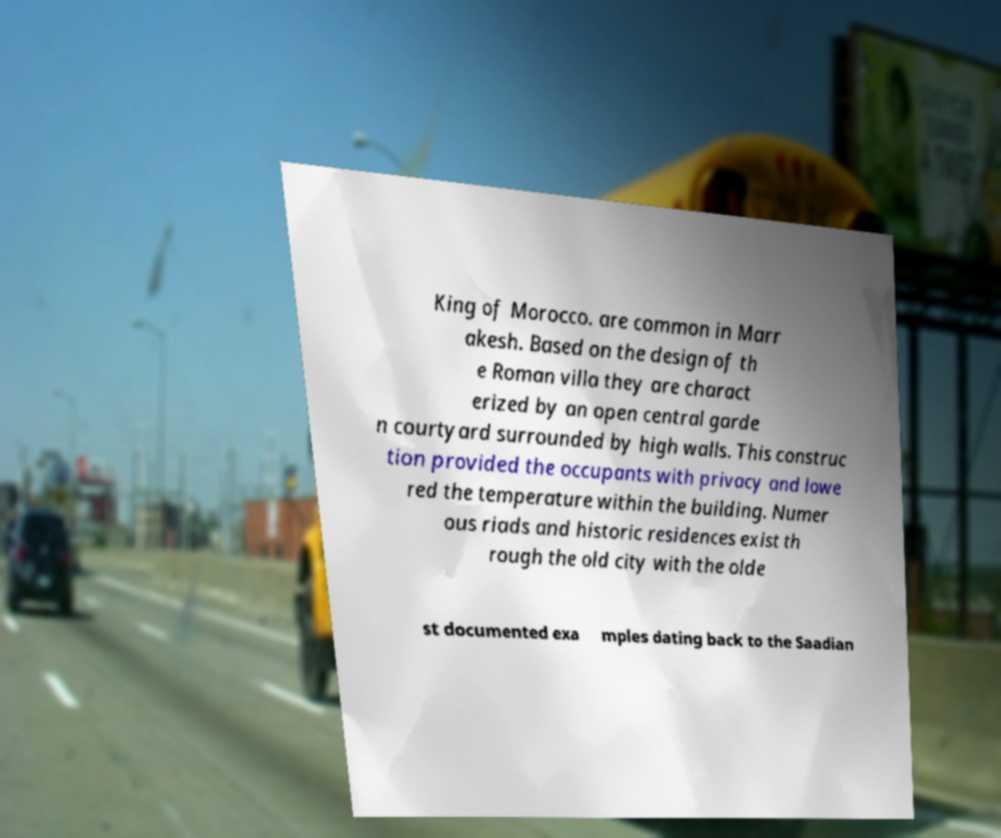There's text embedded in this image that I need extracted. Can you transcribe it verbatim? King of Morocco. are common in Marr akesh. Based on the design of th e Roman villa they are charact erized by an open central garde n courtyard surrounded by high walls. This construc tion provided the occupants with privacy and lowe red the temperature within the building. Numer ous riads and historic residences exist th rough the old city with the olde st documented exa mples dating back to the Saadian 